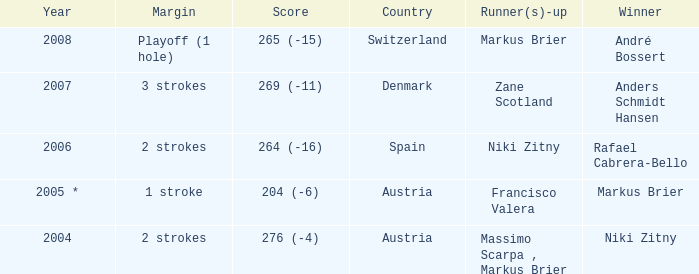Who was the runner-up when the year was 2008? Markus Brier. 